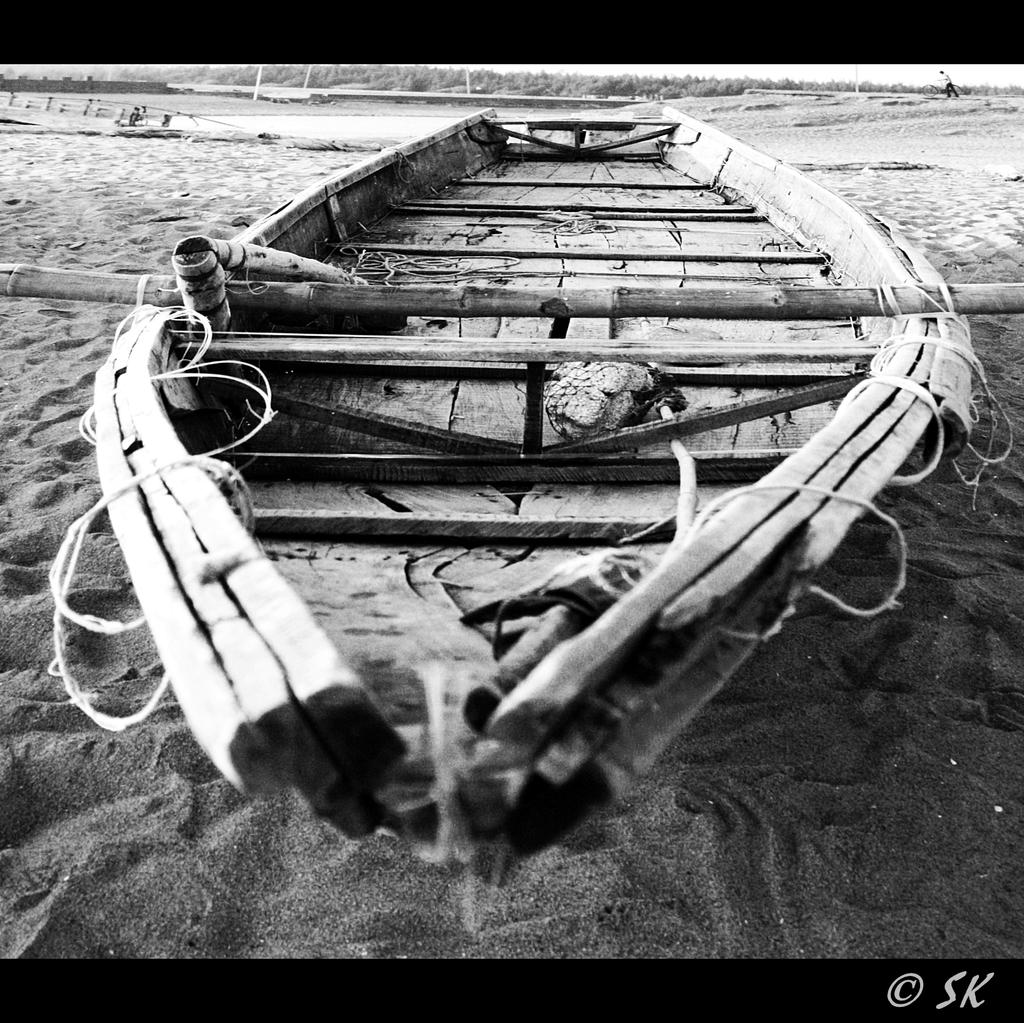What is the main subject of the image? There is a boat in the image. Where is the boat located? The boat is placed on the sand. What type of location is depicted in the image? The image shows a sea shore. What other natural elements can be seen in the image? There are trees in the image. Are there any people in the image? Yes, there is a person in the image. What type of quill is the person using to write on the field in the image? There is no quill or field present in the image. The image features a boat, a sea shore, trees, and a person, but no quill or field. 